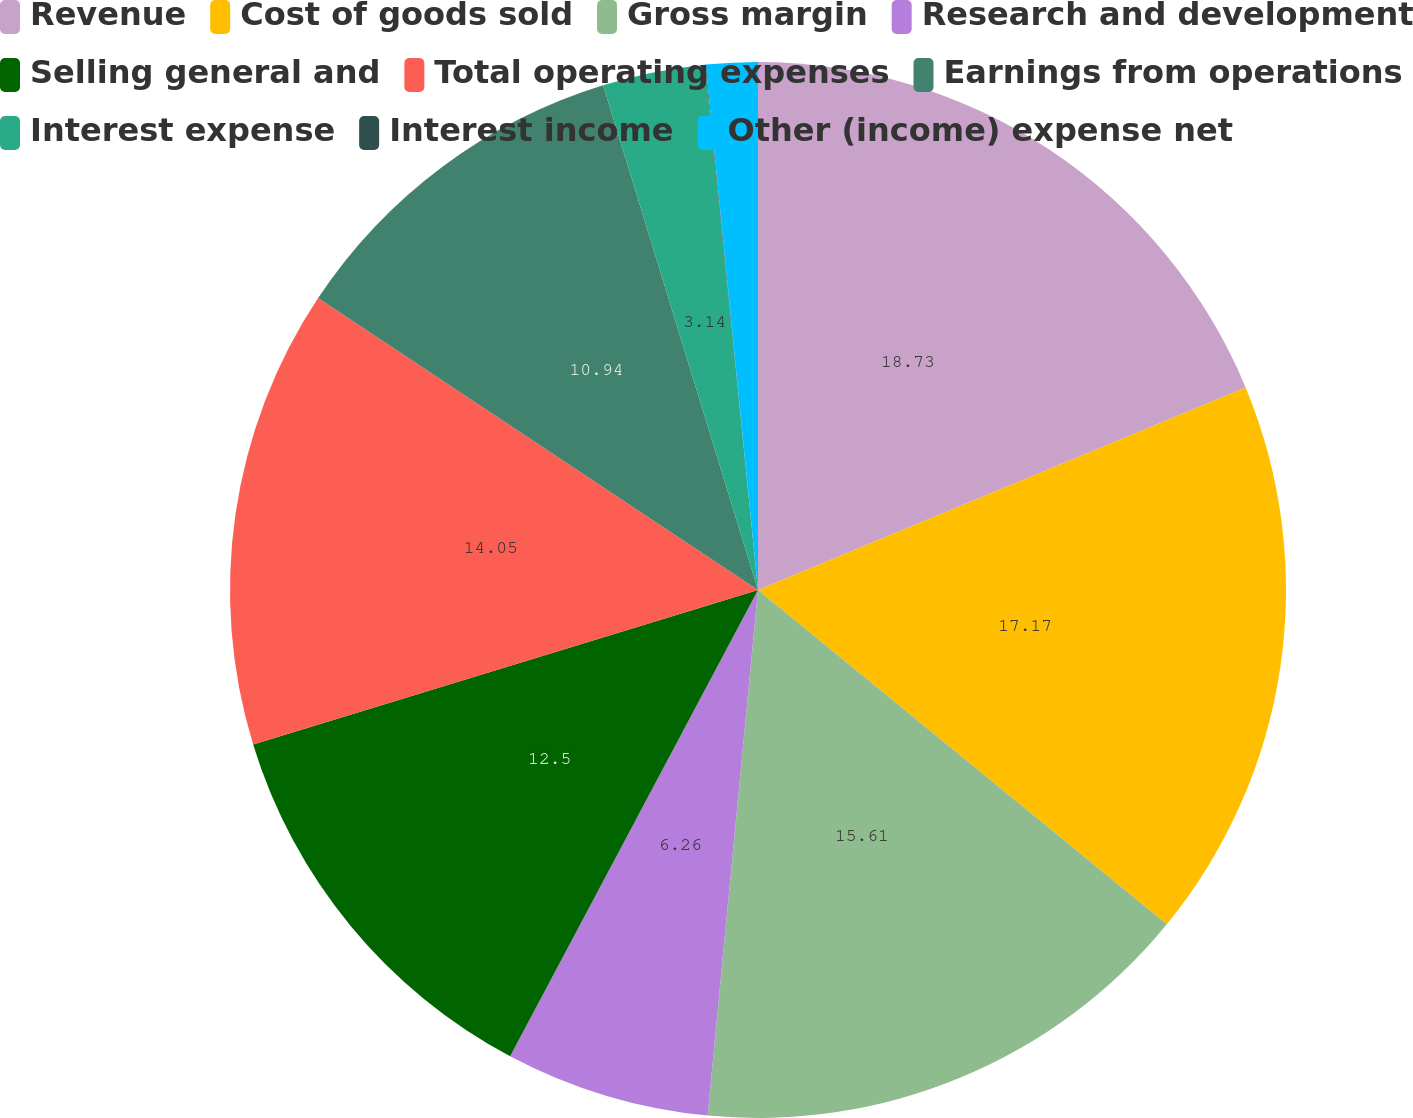Convert chart to OTSL. <chart><loc_0><loc_0><loc_500><loc_500><pie_chart><fcel>Revenue<fcel>Cost of goods sold<fcel>Gross margin<fcel>Research and development<fcel>Selling general and<fcel>Total operating expenses<fcel>Earnings from operations<fcel>Interest expense<fcel>Interest income<fcel>Other (income) expense net<nl><fcel>18.74%<fcel>17.18%<fcel>15.62%<fcel>6.26%<fcel>12.5%<fcel>14.06%<fcel>10.94%<fcel>3.14%<fcel>0.02%<fcel>1.58%<nl></chart> 